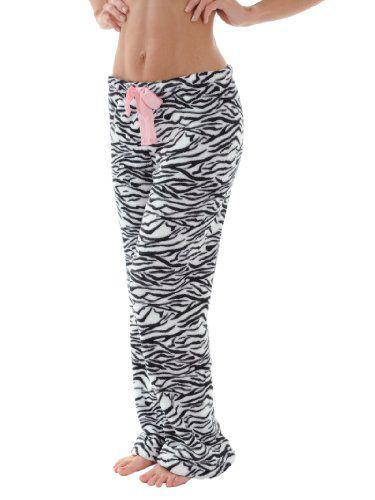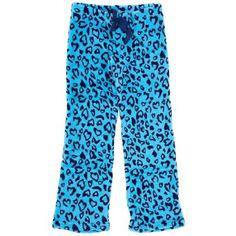The first image is the image on the left, the second image is the image on the right. Considering the images on both sides, is "The image on the left shows part of a woman's stomach." valid? Answer yes or no. Yes. 